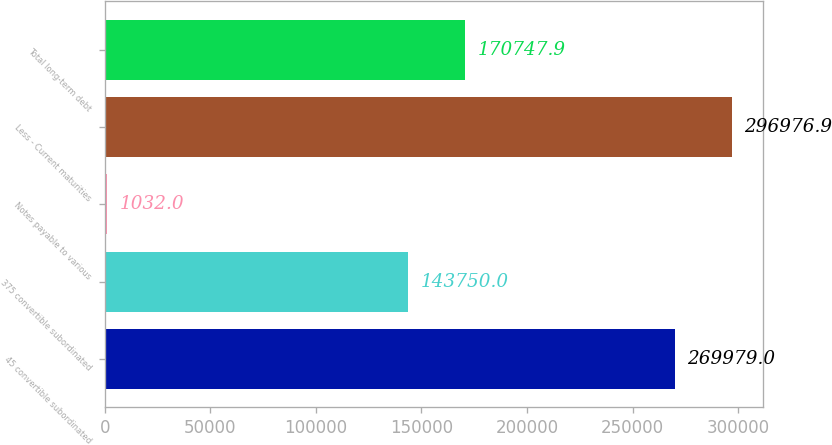Convert chart to OTSL. <chart><loc_0><loc_0><loc_500><loc_500><bar_chart><fcel>45 convertible subordinated<fcel>375 convertible subordinated<fcel>Notes payable to various<fcel>Less - Current maturities<fcel>Total long-term debt<nl><fcel>269979<fcel>143750<fcel>1032<fcel>296977<fcel>170748<nl></chart> 